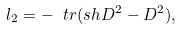Convert formula to latex. <formula><loc_0><loc_0><loc_500><loc_500>l _ { 2 } = - \ t r ( \sl s h { D } ^ { 2 } - D ^ { 2 } ) ,</formula> 